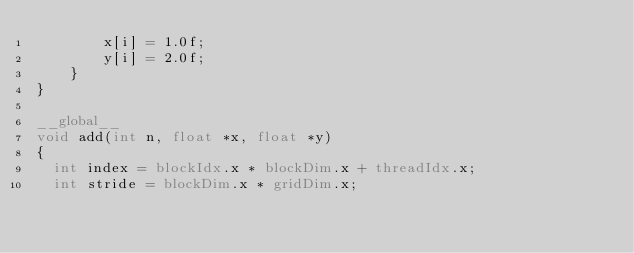<code> <loc_0><loc_0><loc_500><loc_500><_Cuda_>        x[i] = 1.0f;
        y[i] = 2.0f;
    }
}

__global__
void add(int n, float *x, float *y)
{
  int index = blockIdx.x * blockDim.x + threadIdx.x;
  int stride = blockDim.x * gridDim.x;</code> 